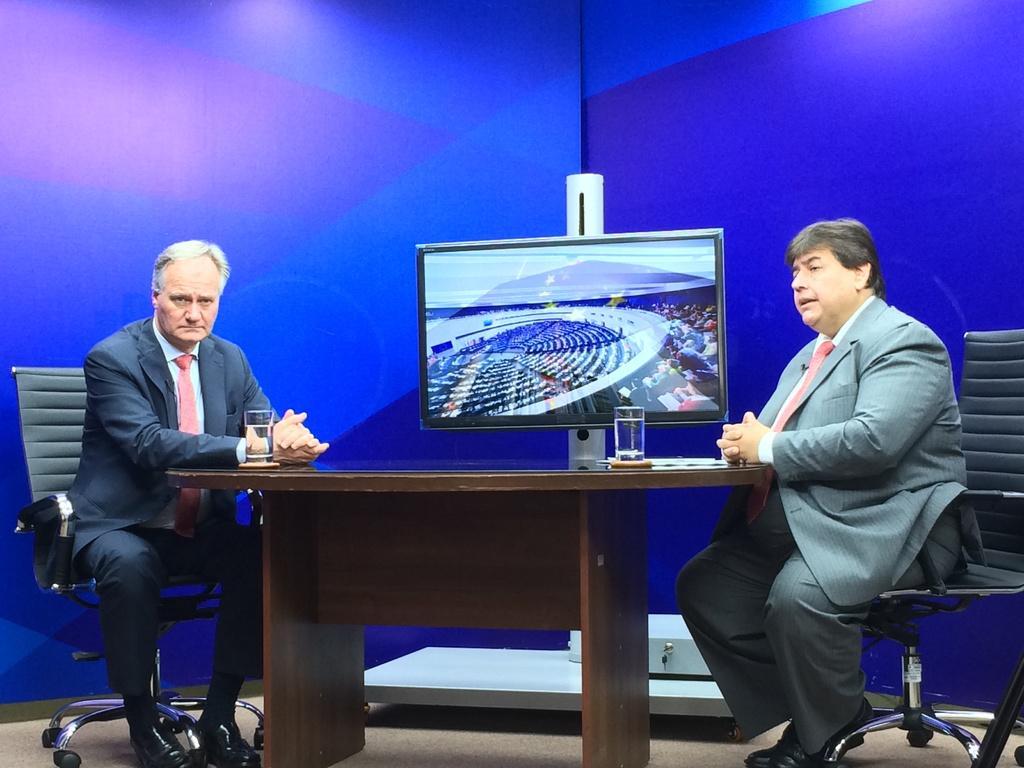Describe this image in one or two sentences. in this picture there are two men sitting in the chairs on either side of the tables on which glasses and television was placed. In the background there is a blue colored wall. 